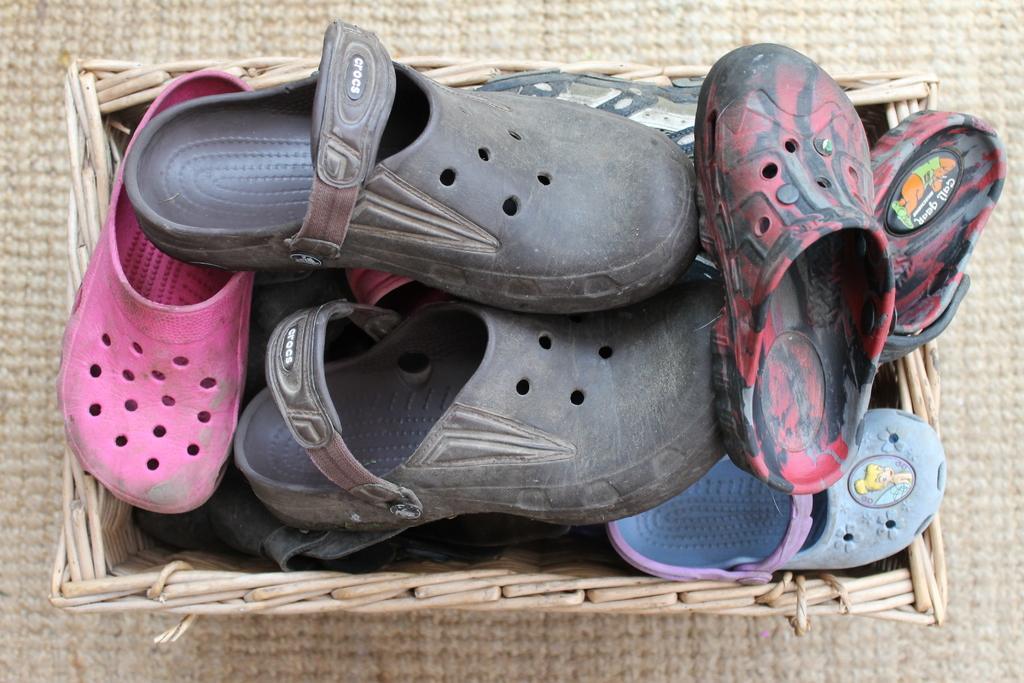In one or two sentences, can you explain what this image depicts? We can see footwear in a basket. 